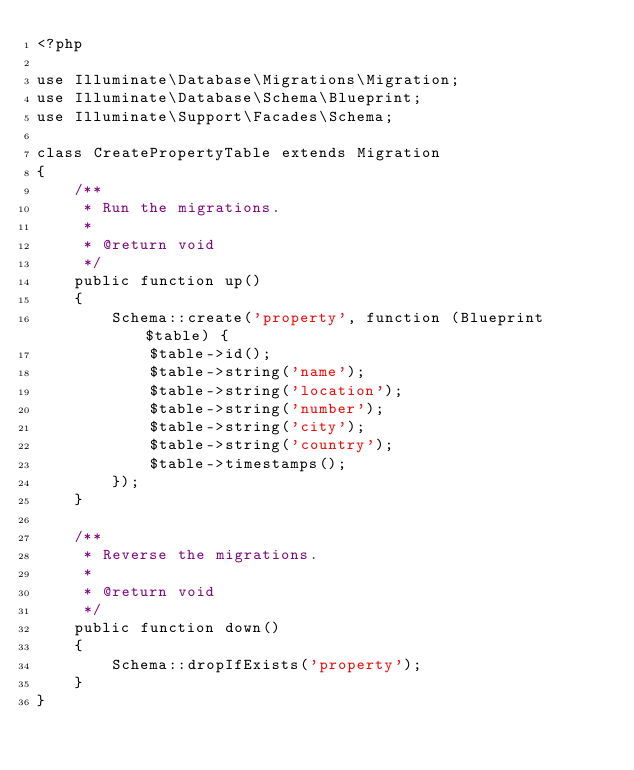<code> <loc_0><loc_0><loc_500><loc_500><_PHP_><?php

use Illuminate\Database\Migrations\Migration;
use Illuminate\Database\Schema\Blueprint;
use Illuminate\Support\Facades\Schema;

class CreatePropertyTable extends Migration
{
    /**
     * Run the migrations.
     *
     * @return void
     */
    public function up()
    {
        Schema::create('property', function (Blueprint $table) {
            $table->id();
            $table->string('name');
            $table->string('location');
            $table->string('number');
            $table->string('city');
            $table->string('country');
            $table->timestamps();
        });
    }

    /**
     * Reverse the migrations.
     *
     * @return void
     */
    public function down()
    {
        Schema::dropIfExists('property');
    }
}
</code> 